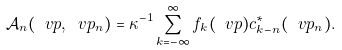<formula> <loc_0><loc_0><loc_500><loc_500>\mathcal { A } _ { n } ( \ v p , \ v p _ { n } ) = \kappa ^ { - 1 } \sum _ { k = - \infty } ^ { \infty } f _ { k } ( \ v p ) c _ { k - n } ^ { * } ( \ v p _ { n } ) .</formula> 